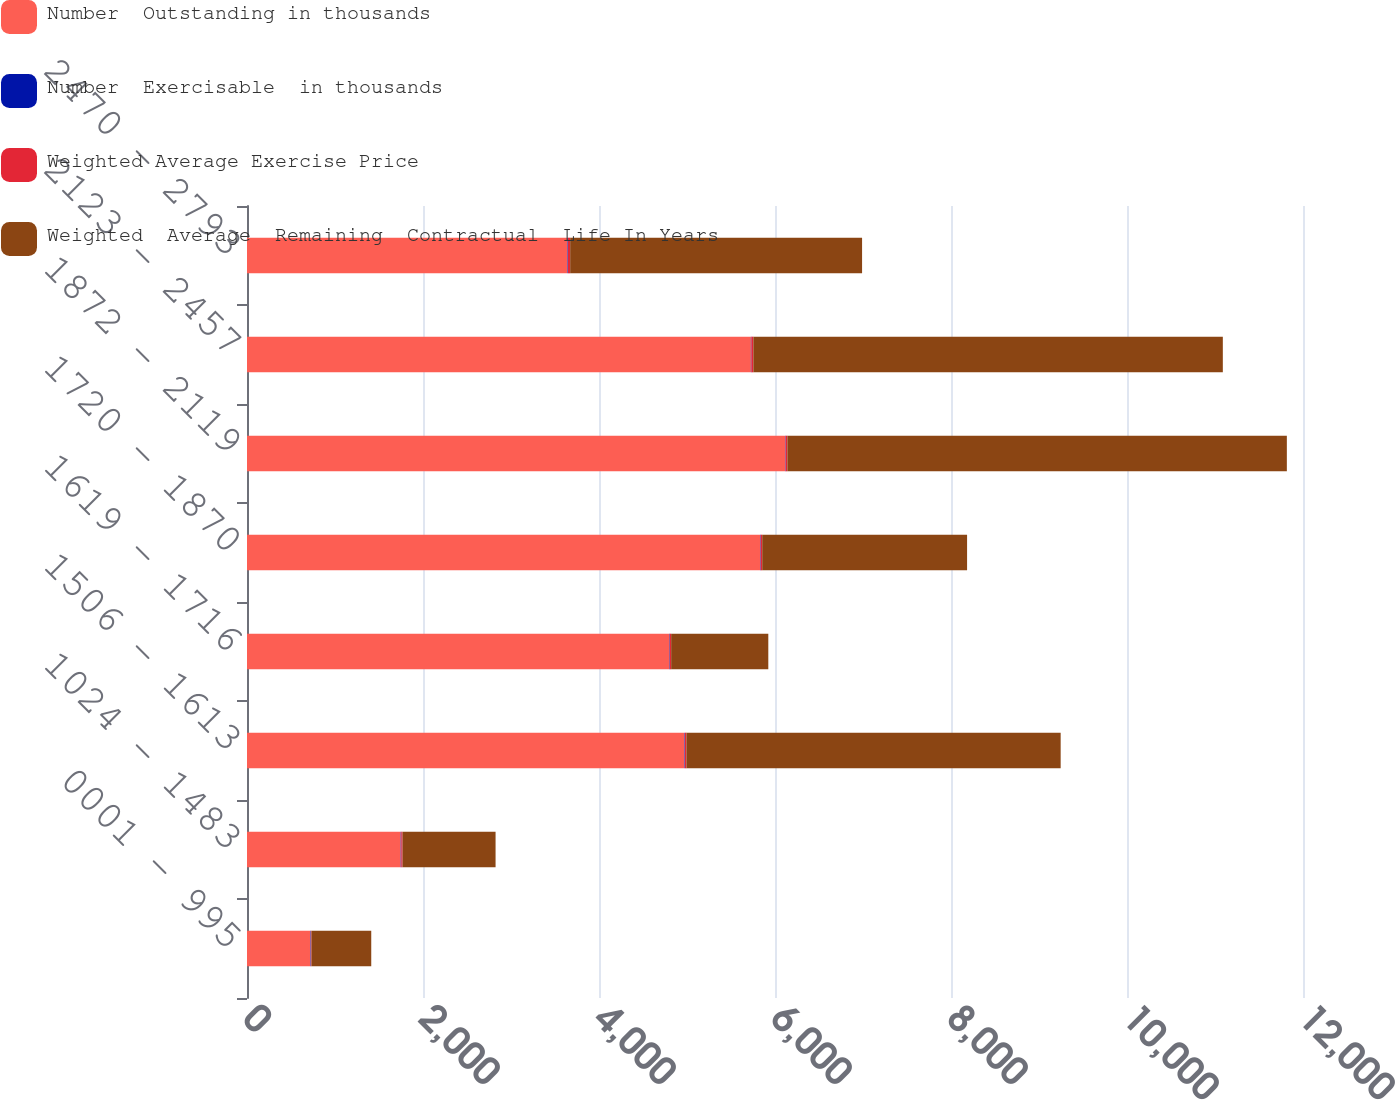<chart> <loc_0><loc_0><loc_500><loc_500><stacked_bar_chart><ecel><fcel>0001 - 995<fcel>1024 - 1483<fcel>1506 - 1613<fcel>1619 - 1716<fcel>1720 - 1870<fcel>1872 - 2119<fcel>2123 - 2457<fcel>2470 - 2793<nl><fcel>Number  Outstanding in thousands<fcel>721<fcel>1747<fcel>4972<fcel>4797<fcel>5831<fcel>6116<fcel>5726<fcel>3641<nl><fcel>Number  Exercisable  in thousands<fcel>5.07<fcel>6.52<fcel>5.08<fcel>5.88<fcel>5.82<fcel>4.74<fcel>5.39<fcel>5.76<nl><fcel>Weighted Average Exercise Price<fcel>6.83<fcel>14.11<fcel>16.06<fcel>17.07<fcel>17.93<fcel>19.71<fcel>22.57<fcel>25.73<nl><fcel>Weighted  Average  Remaining  Contractual  Life In Years<fcel>679<fcel>1057<fcel>4253<fcel>1104<fcel>2328<fcel>5676<fcel>5335<fcel>3317<nl></chart> 